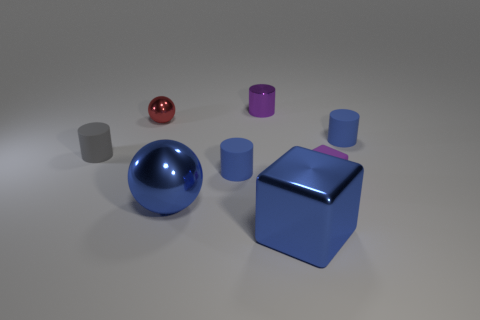There is a large blue thing that is the same shape as the tiny purple rubber thing; what is its material?
Ensure brevity in your answer.  Metal. What is the material of the purple thing in front of the metal ball that is behind the purple object that is right of the shiny cylinder?
Your response must be concise. Rubber. What is the size of the purple thing that is the same material as the red thing?
Keep it short and to the point. Small. Are there any other things that have the same color as the tiny shiny cylinder?
Your answer should be very brief. Yes. There is a block in front of the small rubber block; is its color the same as the cylinder that is on the right side of the shiny block?
Offer a very short reply. Yes. There is a small metallic object left of the blue sphere; what color is it?
Keep it short and to the point. Red. There is a blue rubber thing that is behind the gray rubber thing; is its size the same as the tiny matte block?
Make the answer very short. Yes. Are there fewer tiny purple shiny cylinders than red rubber blocks?
Your answer should be very brief. No. What shape is the metal thing that is the same color as the matte block?
Give a very brief answer. Cylinder. What number of purple cylinders are on the left side of the tiny gray thing?
Ensure brevity in your answer.  0. 